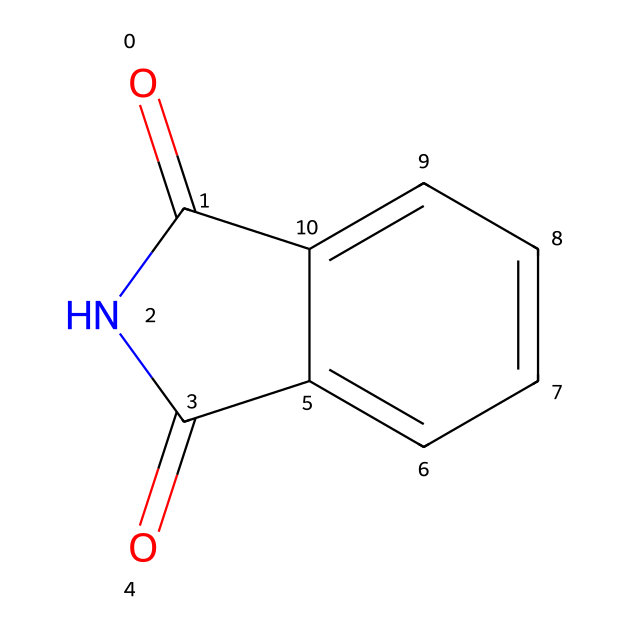What is the molecular formula of phthalimide? The chemical structure shows two carbonyl groups (C=O), which can be counted from the structure (one on the nitrogen and one on the benzene-ring side), six carbons from the benzene ring, two nitrogens, and four hydrogens. Therefore, the accumulated counts give the formula C8H5N1O2.
Answer: C8H5N1O2 How many rings are present in the structure of phthalimide? The structure of phthalimide has one six-membered ring originating from the aromatic part of the molecule and another five-membered ring that includes the carbonyl and nitrogen, resulting in a total of two rings.
Answer: 2 What type of functional groups are present in phthalimide? Reviewing the structure, the presence of both carbonyl groups (C=O) indicates imides, while the nitrogen in the five-membered ring indicates an amide-like component, classifying it under imide functional groups.
Answer: carbonyl and imide How many carbon atoms are involved in the phthalimide structure? By analyzing the SMILES representation, we can see it has six aromatic carbons and two carbonyl carbons, totaling eight carbon atoms in the structure of phthalimide.
Answer: 8 What role does the nitrogen atom play in phthalimide? The nitrogen atom is part of an imide functional group as it forms part of a cyclic structure with carbonyl. This contributes to the unique properties which include thermal stability and potential interactions with other materials, especially in coatings.
Answer: imide functional group What is the significance of the carbonyl groups in phthalimide? The carbonyl groups are integral to the properties of the chemical; they impart reactivity and stability, which are crucial for applications in coatings, especially in electronic materials like antenna systems.
Answer: impart reactivity and stability 